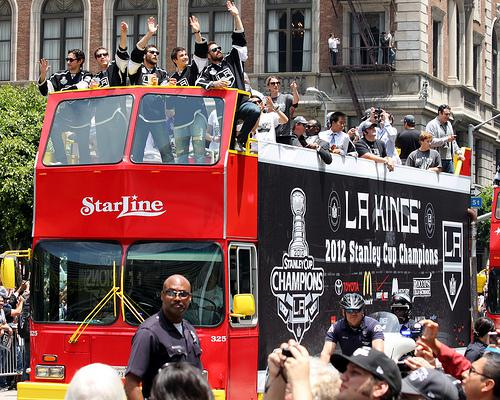Question: what colors are the LA Kings jerseys?
Choices:
A. White and black.
B. Black and silver.
C. Gold and purple.
D. Black and white.
Answer with the letter. Answer: D Question: where was this picture taken?
Choices:
A. Pittsburgh.
B. Chicago.
C. Utah.
D. L.A.
Answer with the letter. Answer: D Question: what color is the bus?
Choices:
A. Red.
B. Yellow.
C. White.
D. Brown.
Answer with the letter. Answer: A Question: what are the team members doing?
Choices:
A. Waving.
B. Practicing.
C. Celebrating.
D. Talking.
Answer with the letter. Answer: A Question: what sports team is this parade for?
Choices:
A. LA Kings.
B. NY Yankees.
C. Red Sox.
D. Dallas Cowboys.
Answer with the letter. Answer: A 